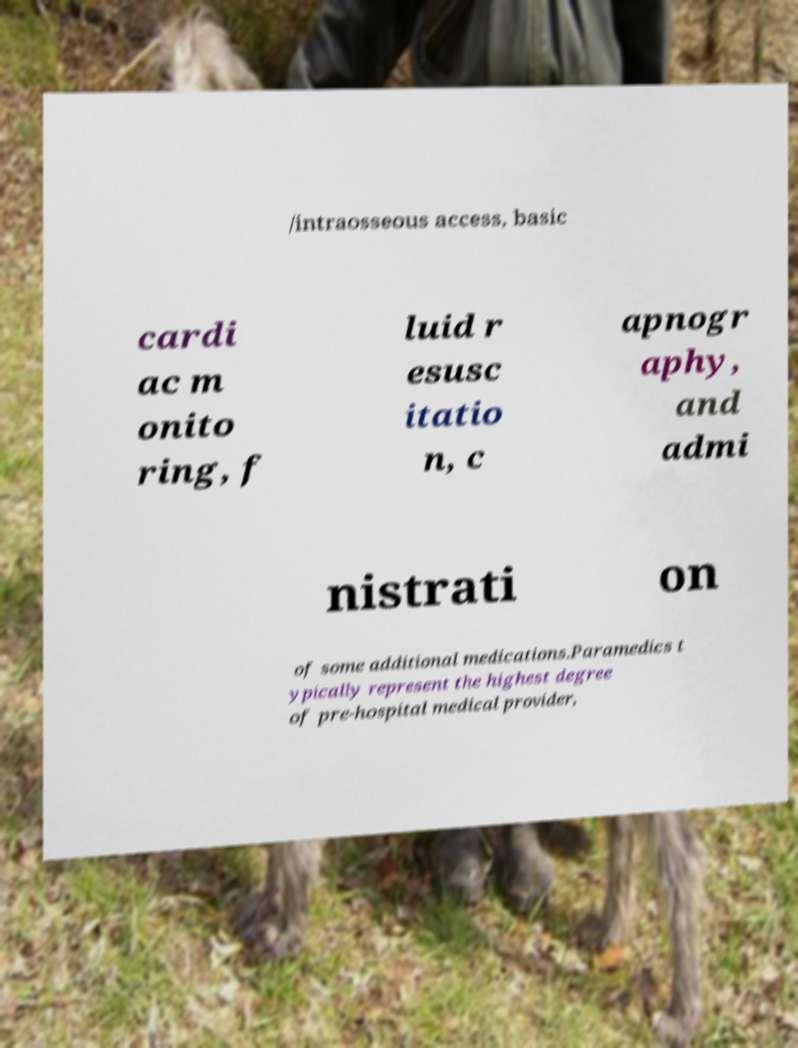Could you assist in decoding the text presented in this image and type it out clearly? /intraosseous access, basic cardi ac m onito ring, f luid r esusc itatio n, c apnogr aphy, and admi nistrati on of some additional medications.Paramedics t ypically represent the highest degree of pre-hospital medical provider, 